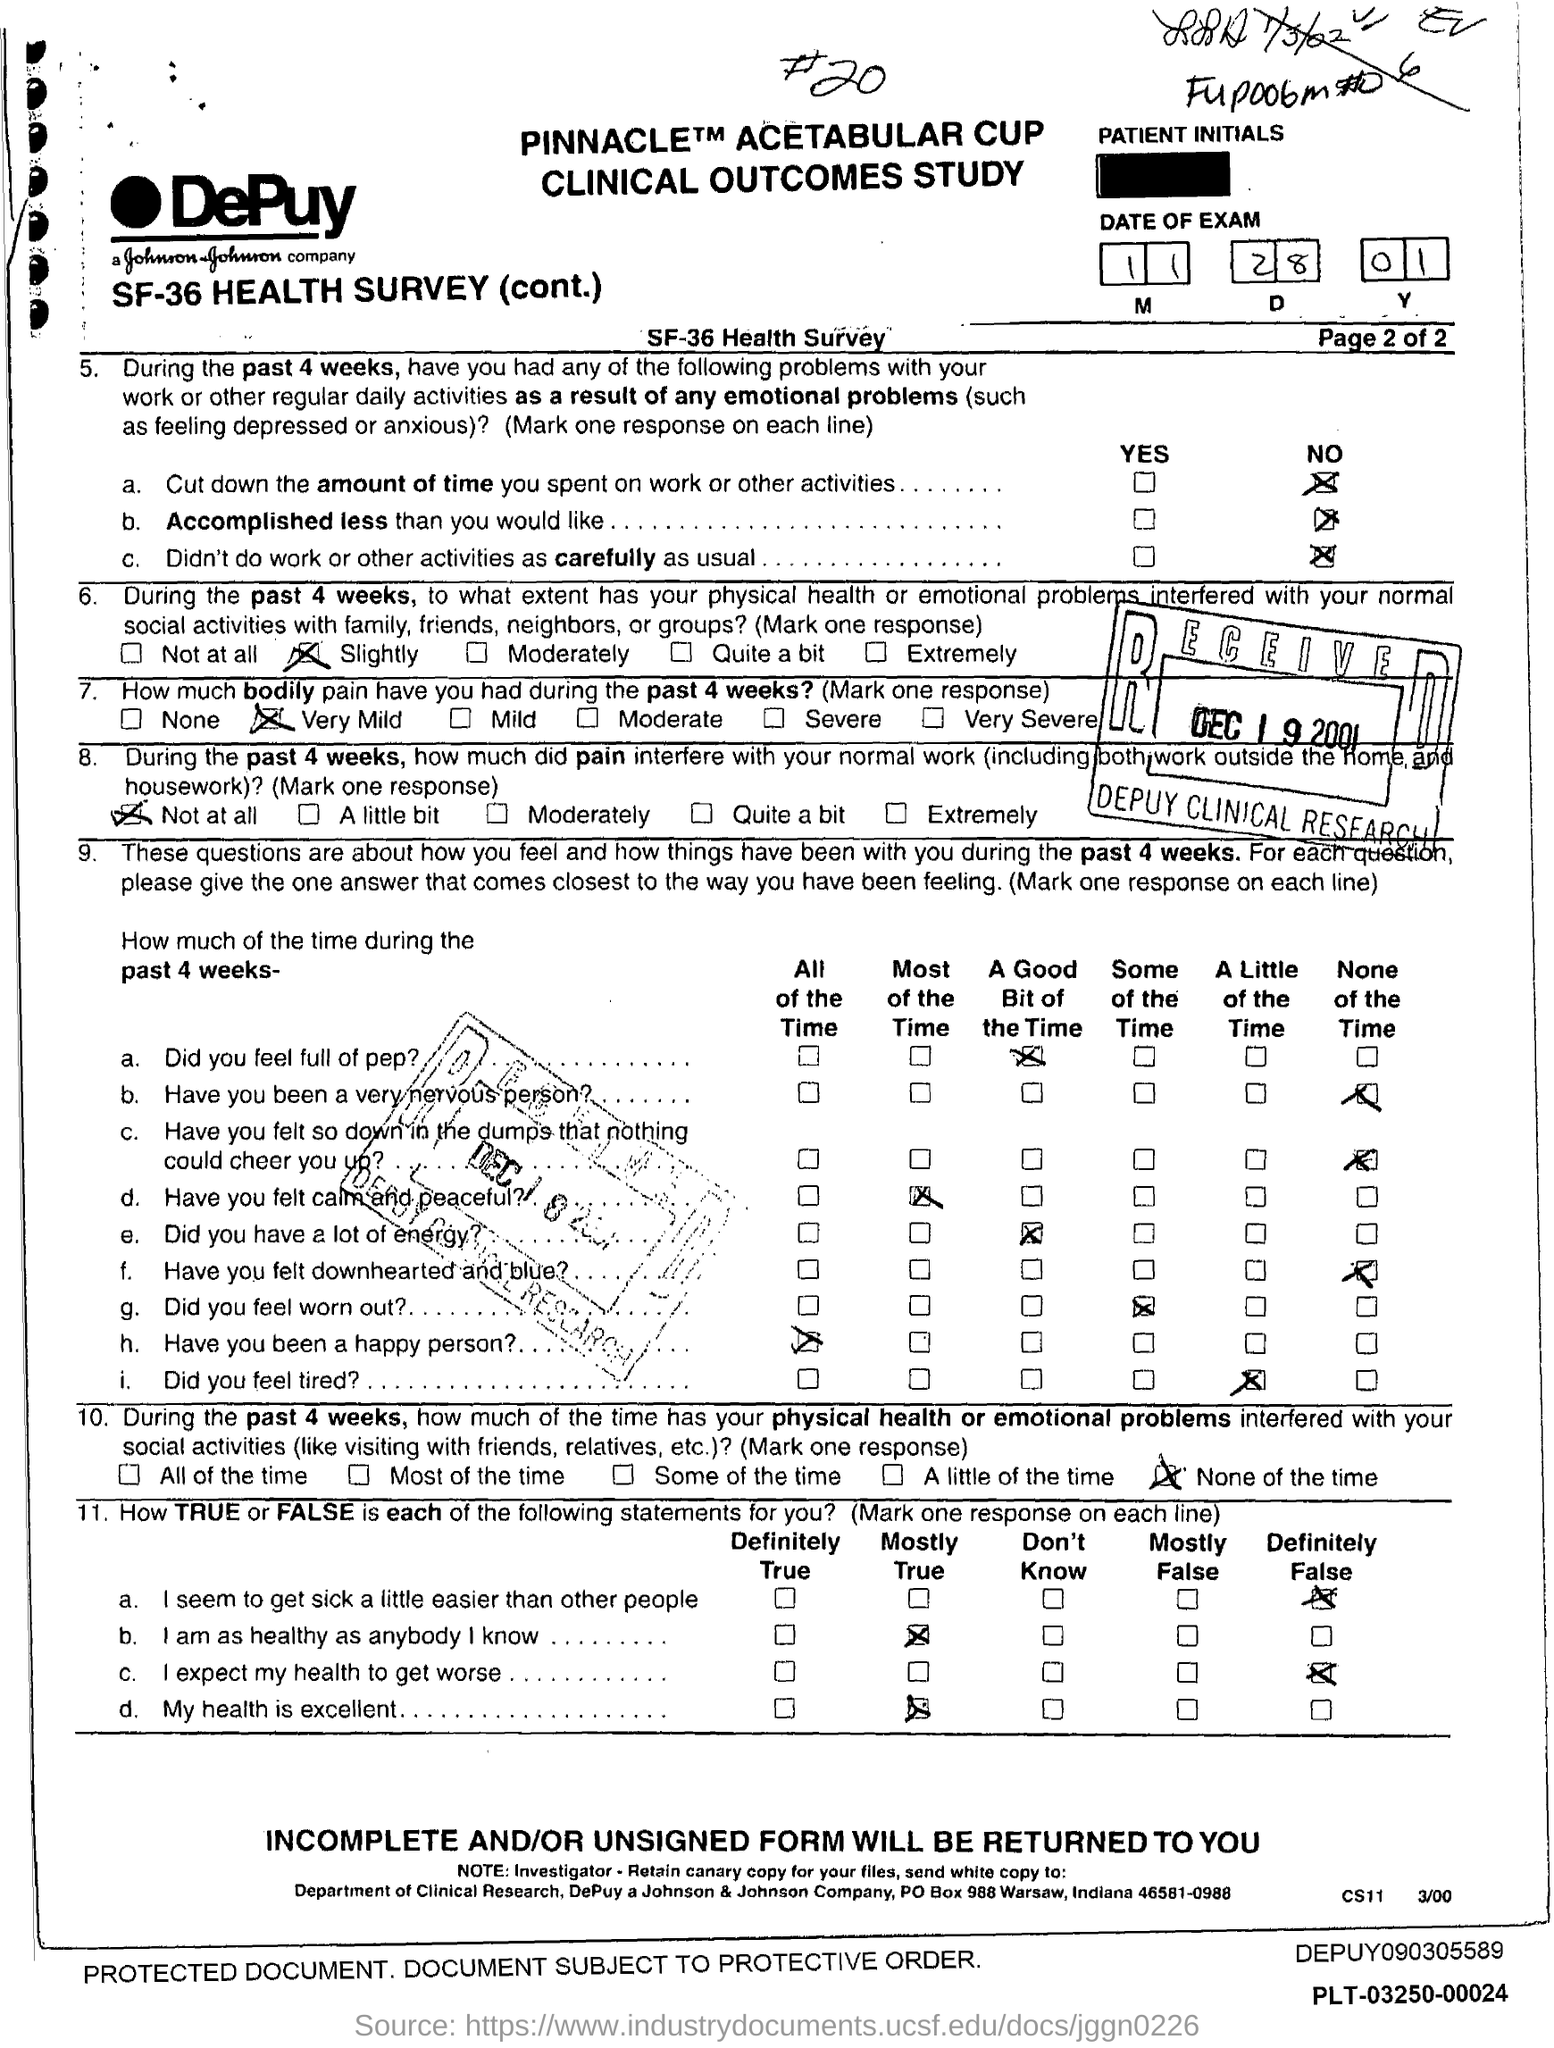What is the date of the exam given in the form?
Offer a terse response. 11.28.01. How much bodily pain have you had during the past 4 weeks as per the health survey?
Provide a short and direct response. VERY MILD. 